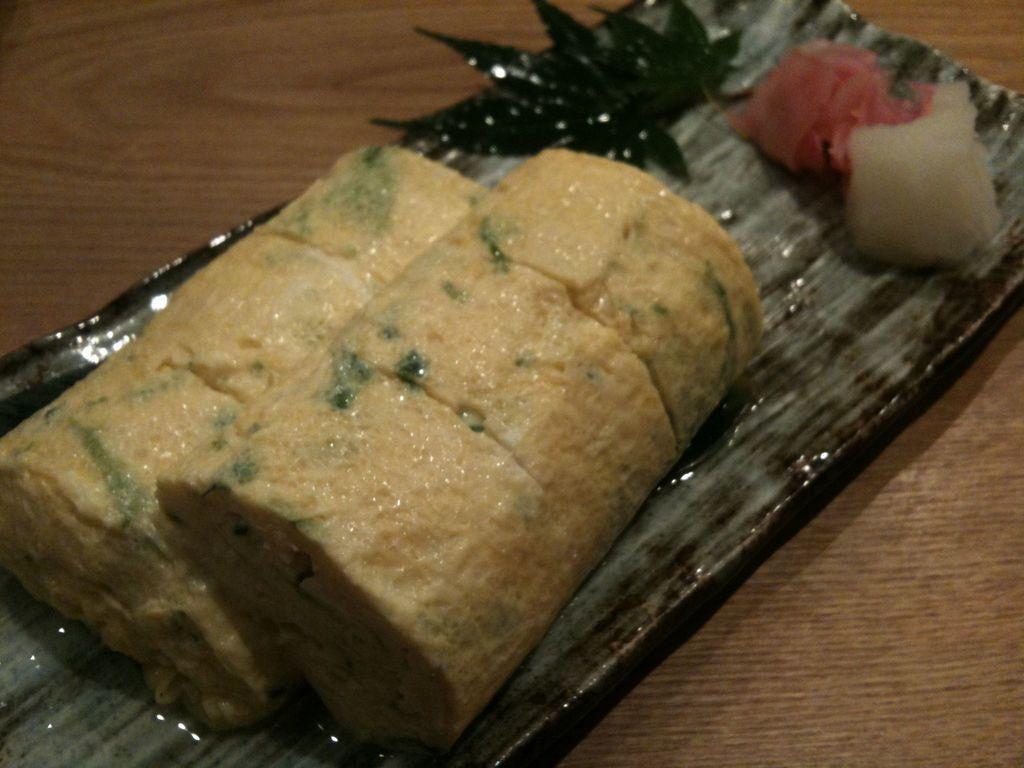Can you describe this image briefly? In the foreground of this image, there is a food item on a tray on the wooden surface. 